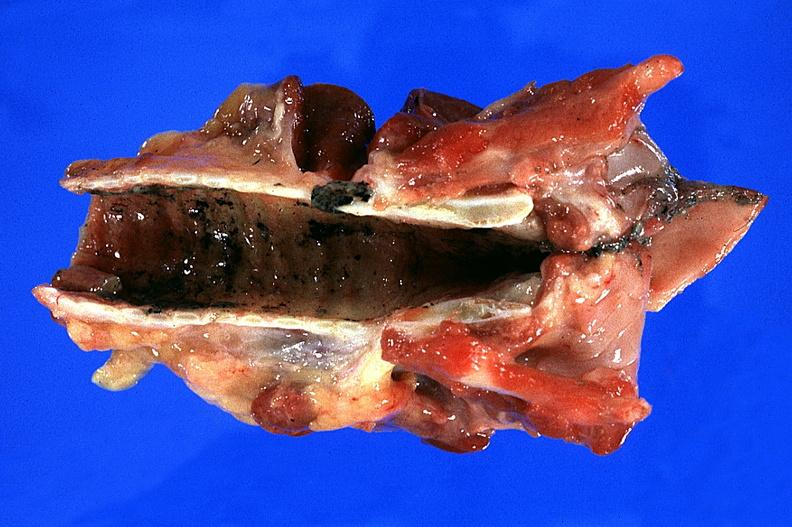does umbilical cord show trachea?
Answer the question using a single word or phrase. No 